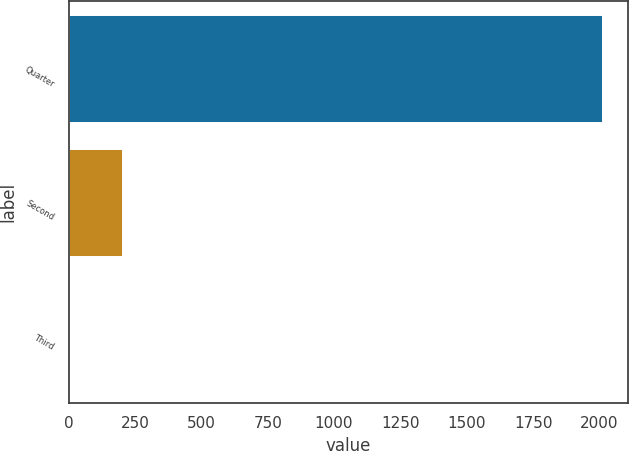Convert chart to OTSL. <chart><loc_0><loc_0><loc_500><loc_500><bar_chart><fcel>Quarter<fcel>Second<fcel>Third<nl><fcel>2008<fcel>201.46<fcel>0.73<nl></chart> 